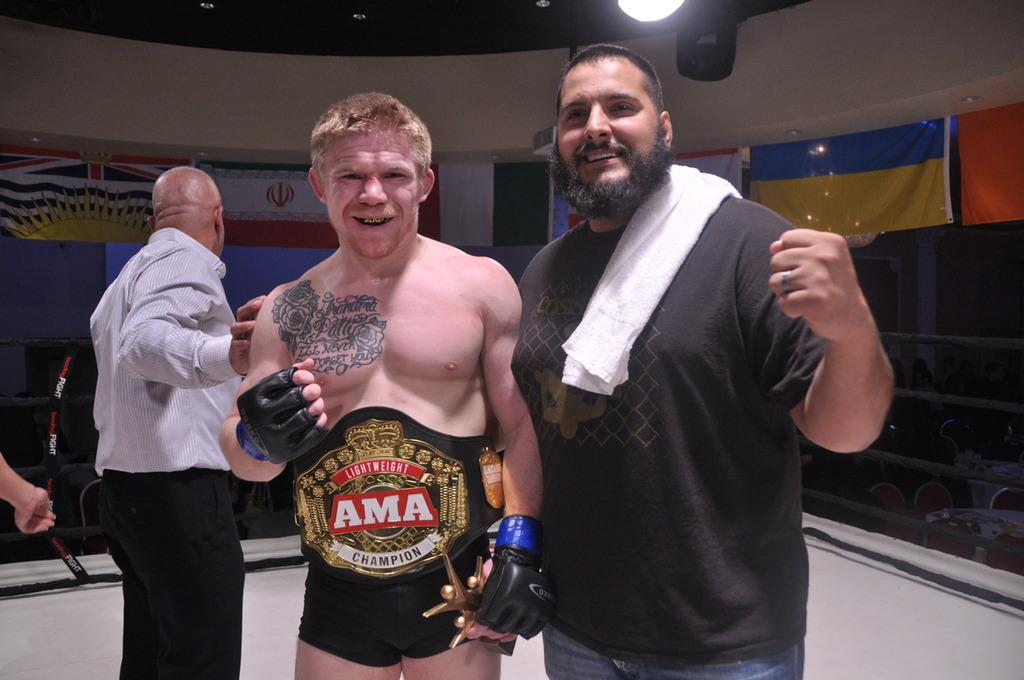Provide a one-sentence caption for the provided image. Some fighters standing around, one of whom is wearing a belt reading AMA>. 